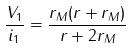Convert formula to latex. <formula><loc_0><loc_0><loc_500><loc_500>\frac { V _ { 1 } } { i _ { 1 } } = \frac { r _ { M } ( r + r _ { M } ) } { r + 2 r _ { M } }</formula> 